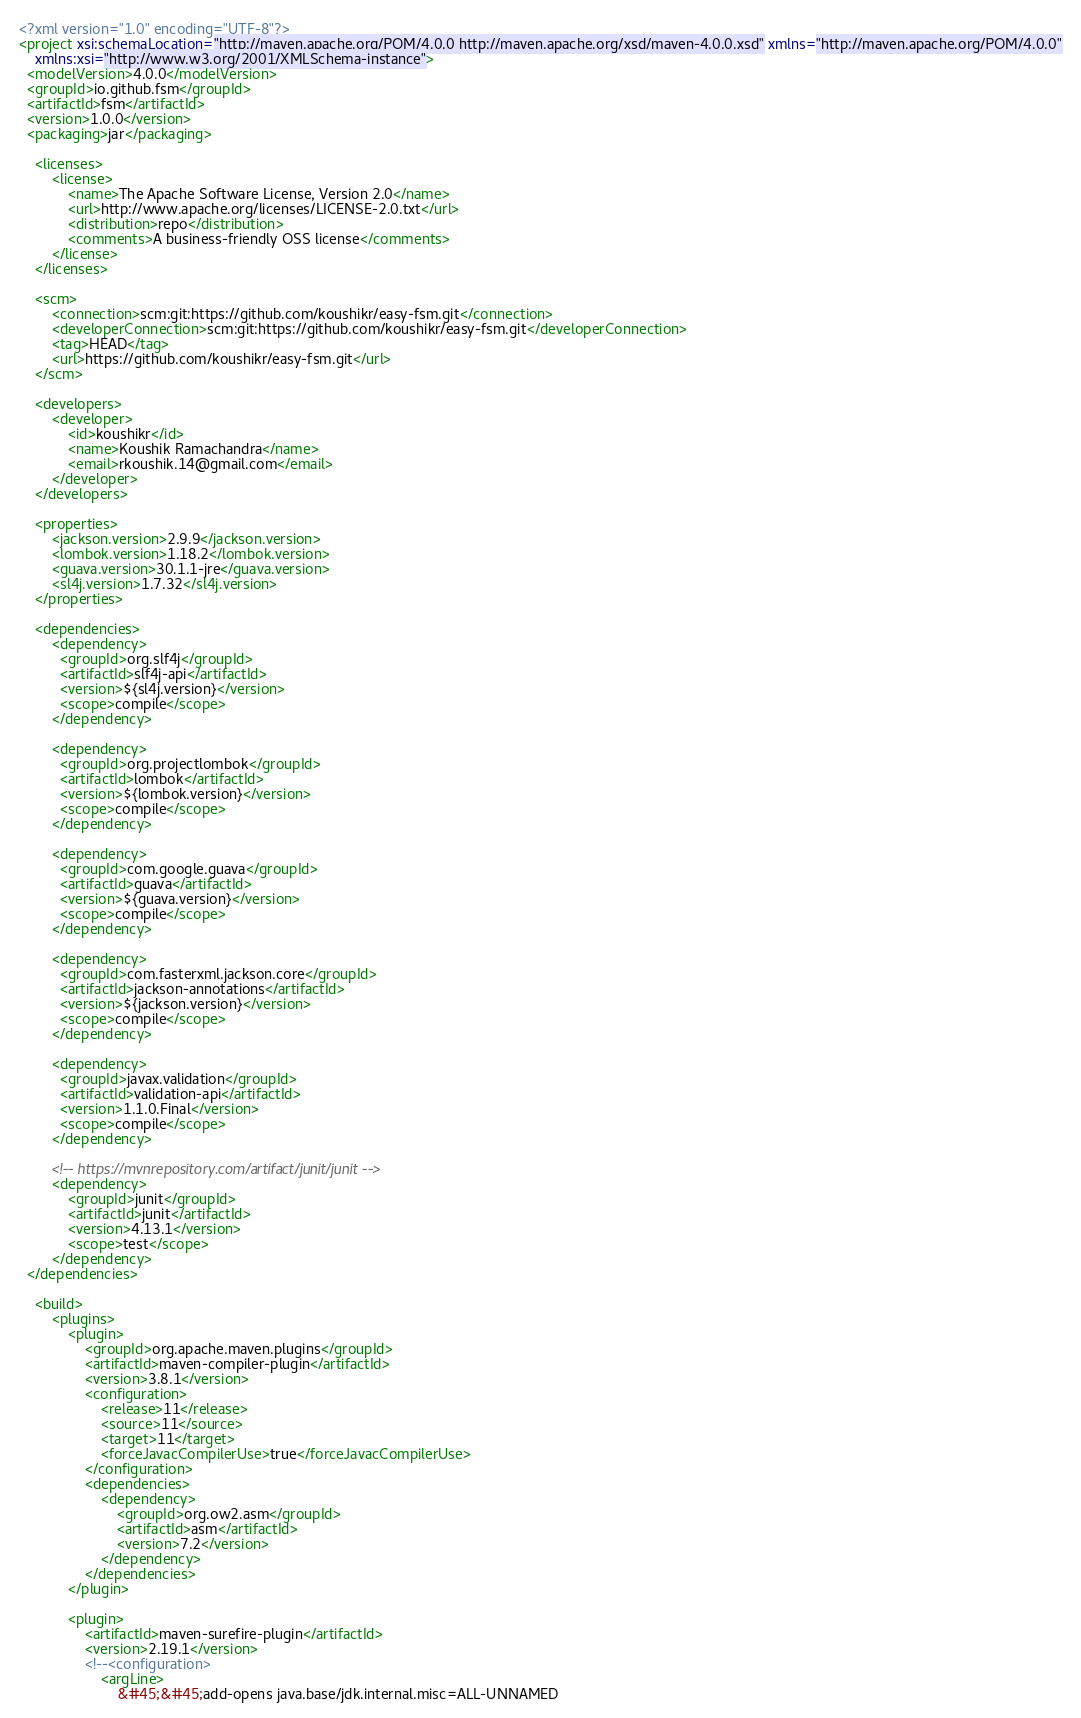Convert code to text. <code><loc_0><loc_0><loc_500><loc_500><_XML_><?xml version="1.0" encoding="UTF-8"?>
<project xsi:schemaLocation="http://maven.apache.org/POM/4.0.0 http://maven.apache.org/xsd/maven-4.0.0.xsd" xmlns="http://maven.apache.org/POM/4.0.0"
    xmlns:xsi="http://www.w3.org/2001/XMLSchema-instance">
  <modelVersion>4.0.0</modelVersion>
  <groupId>io.github.fsm</groupId>
  <artifactId>fsm</artifactId>
  <version>1.0.0</version>
  <packaging>jar</packaging>

    <licenses>
        <license>
            <name>The Apache Software License, Version 2.0</name>
            <url>http://www.apache.org/licenses/LICENSE-2.0.txt</url>
            <distribution>repo</distribution>
            <comments>A business-friendly OSS license</comments>
        </license>
    </licenses>

    <scm>
        <connection>scm:git:https://github.com/koushikr/easy-fsm.git</connection>
        <developerConnection>scm:git:https://github.com/koushikr/easy-fsm.git</developerConnection>
        <tag>HEAD</tag>
        <url>https://github.com/koushikr/easy-fsm.git</url>
    </scm>

    <developers>
        <developer>
            <id>koushikr</id>
            <name>Koushik Ramachandra</name>
            <email>rkoushik.14@gmail.com</email>
        </developer>
    </developers>

    <properties>
        <jackson.version>2.9.9</jackson.version>
        <lombok.version>1.18.2</lombok.version>
        <guava.version>30.1.1-jre</guava.version>
        <sl4j.version>1.7.32</sl4j.version>
    </properties>

    <dependencies>
        <dependency>
          <groupId>org.slf4j</groupId>
          <artifactId>slf4j-api</artifactId>
          <version>${sl4j.version}</version>
          <scope>compile</scope>
        </dependency>

        <dependency>
          <groupId>org.projectlombok</groupId>
          <artifactId>lombok</artifactId>
          <version>${lombok.version}</version>
          <scope>compile</scope>
        </dependency>

        <dependency>
          <groupId>com.google.guava</groupId>
          <artifactId>guava</artifactId>
          <version>${guava.version}</version>
          <scope>compile</scope>
        </dependency>

        <dependency>
          <groupId>com.fasterxml.jackson.core</groupId>
          <artifactId>jackson-annotations</artifactId>
          <version>${jackson.version}</version>
          <scope>compile</scope>
        </dependency>

        <dependency>
          <groupId>javax.validation</groupId>
          <artifactId>validation-api</artifactId>
          <version>1.1.0.Final</version>
          <scope>compile</scope>
        </dependency>

        <!-- https://mvnrepository.com/artifact/junit/junit -->
        <dependency>
            <groupId>junit</groupId>
            <artifactId>junit</artifactId>
            <version>4.13.1</version>
            <scope>test</scope>
        </dependency>
  </dependencies>

    <build>
        <plugins>
            <plugin>
                <groupId>org.apache.maven.plugins</groupId>
                <artifactId>maven-compiler-plugin</artifactId>
                <version>3.8.1</version>
                <configuration>
                    <release>11</release>
                    <source>11</source>
                    <target>11</target>
                    <forceJavacCompilerUse>true</forceJavacCompilerUse>
                </configuration>
                <dependencies>
                    <dependency>
                        <groupId>org.ow2.asm</groupId>
                        <artifactId>asm</artifactId>
                        <version>7.2</version>
                    </dependency>
                </dependencies>
            </plugin>

            <plugin>
                <artifactId>maven-surefire-plugin</artifactId>
                <version>2.19.1</version>
                <!--<configuration>
                    <argLine>
                        &#45;&#45;add-opens java.base/jdk.internal.misc=ALL-UNNAMED</code> 